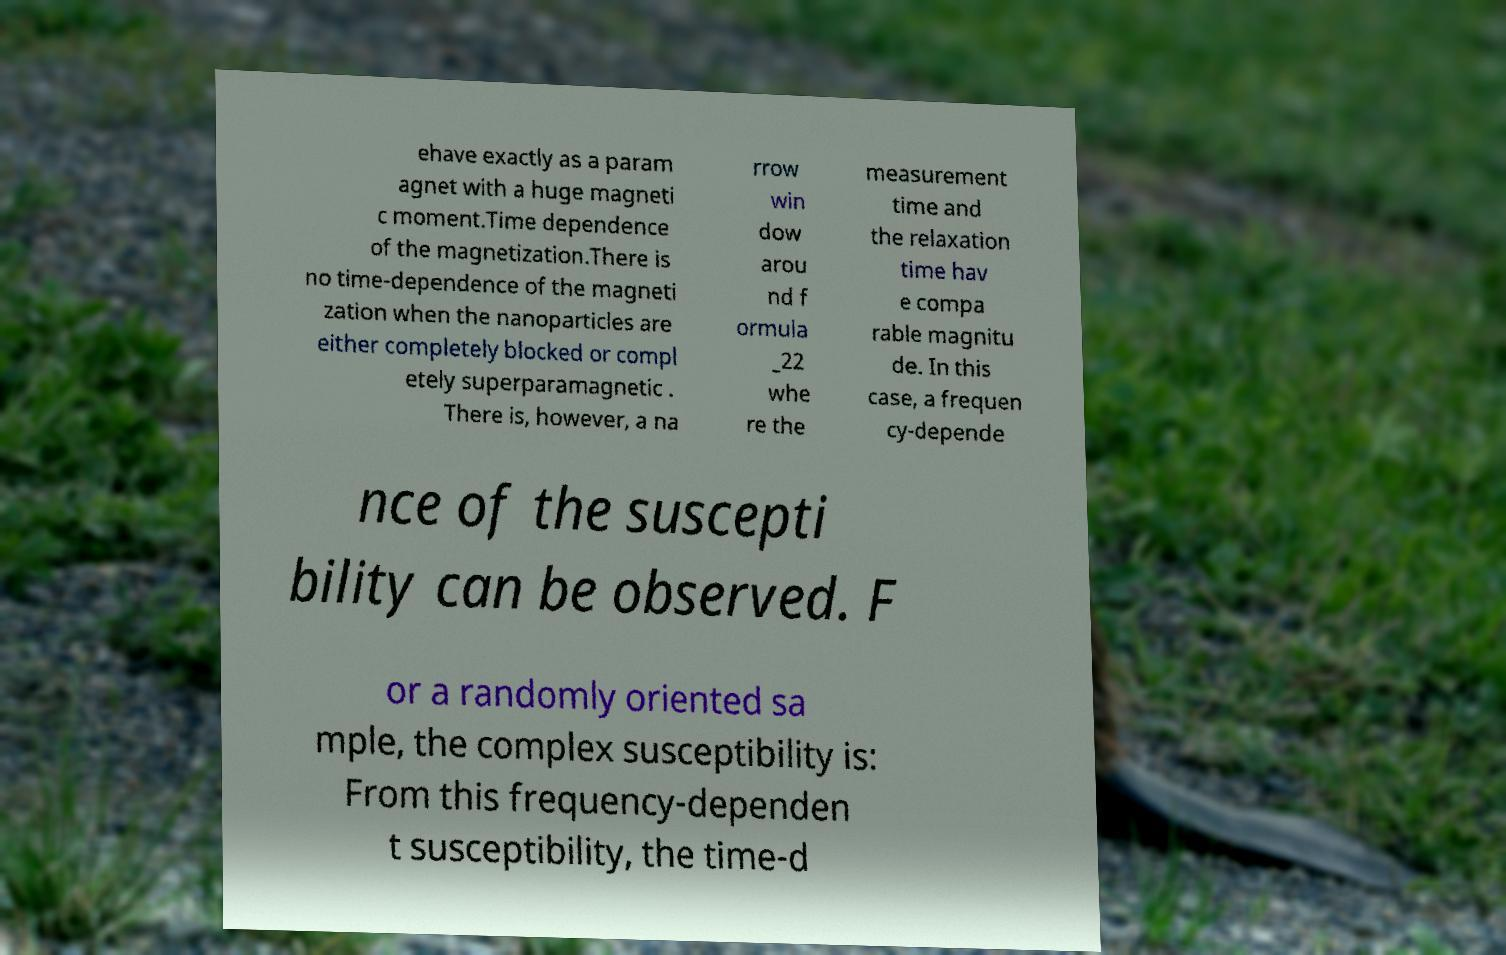Could you extract and type out the text from this image? ehave exactly as a param agnet with a huge magneti c moment.Time dependence of the magnetization.There is no time-dependence of the magneti zation when the nanoparticles are either completely blocked or compl etely superparamagnetic . There is, however, a na rrow win dow arou nd f ormula _22 whe re the measurement time and the relaxation time hav e compa rable magnitu de. In this case, a frequen cy-depende nce of the suscepti bility can be observed. F or a randomly oriented sa mple, the complex susceptibility is: From this frequency-dependen t susceptibility, the time-d 